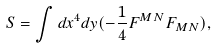<formula> <loc_0><loc_0><loc_500><loc_500>S = \int d x ^ { 4 } d y ( - \frac { 1 } { 4 } F ^ { M N } F _ { M N } ) ,</formula> 